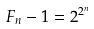Convert formula to latex. <formula><loc_0><loc_0><loc_500><loc_500>F _ { n } - 1 = 2 ^ { 2 ^ { n } }</formula> 